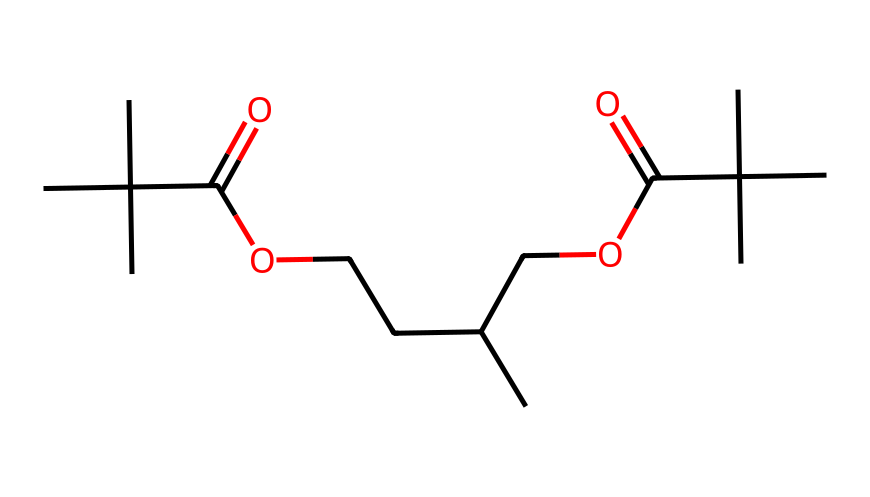What is the number of carbon atoms in the structure? By analyzing the SMILES representation, we count all the carbon atoms present. The structure shows multiple carbon atoms such as those in carbon chains and branches, leading to a total count of 16.
Answer: 16 How many ester functional groups are present? The SMILES representation shows 'C(=O)O' segments in two locations, indicating the presence of two ester functional groups in the structure.
Answer: 2 What is the molecular weight of the compound? To determine the molecular weight, we consider the atomic weights of each atom present in the SMILES representation: carbons, oxygens, and hydrogens. The calculation leads to an approximate molecular weight of 290 g/mol.
Answer: 290 g/mol What type of polymer is this structure most associated with? The presence of the repeating ester linkages in the polymer chain suggests that this structure is most associated with aliphatic polyesters.
Answer: aliphatic polyester What would be the polymeric property related to biodegradability in this structure? The structure contains ester bonds which are susceptible to hydrolysis by water and biological processes, thus contributing to its biodegradable property.
Answer: ease of hydrolysis What is the significance of the branched structure in this polymer? The branched nature helps in providing flexibility and durability to the biodegradable shopping bags, improving their mechanical properties while maintaining its environmental advantages.
Answer: flexibility and durability 